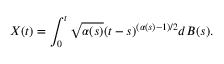Convert formula to latex. <formula><loc_0><loc_0><loc_500><loc_500>X ( t ) = \int _ { 0 } ^ { t } \sqrt { \alpha ( s ) } ( t - s ) ^ { ( \alpha ( s ) - 1 ) / 2 } d B ( s ) .</formula> 